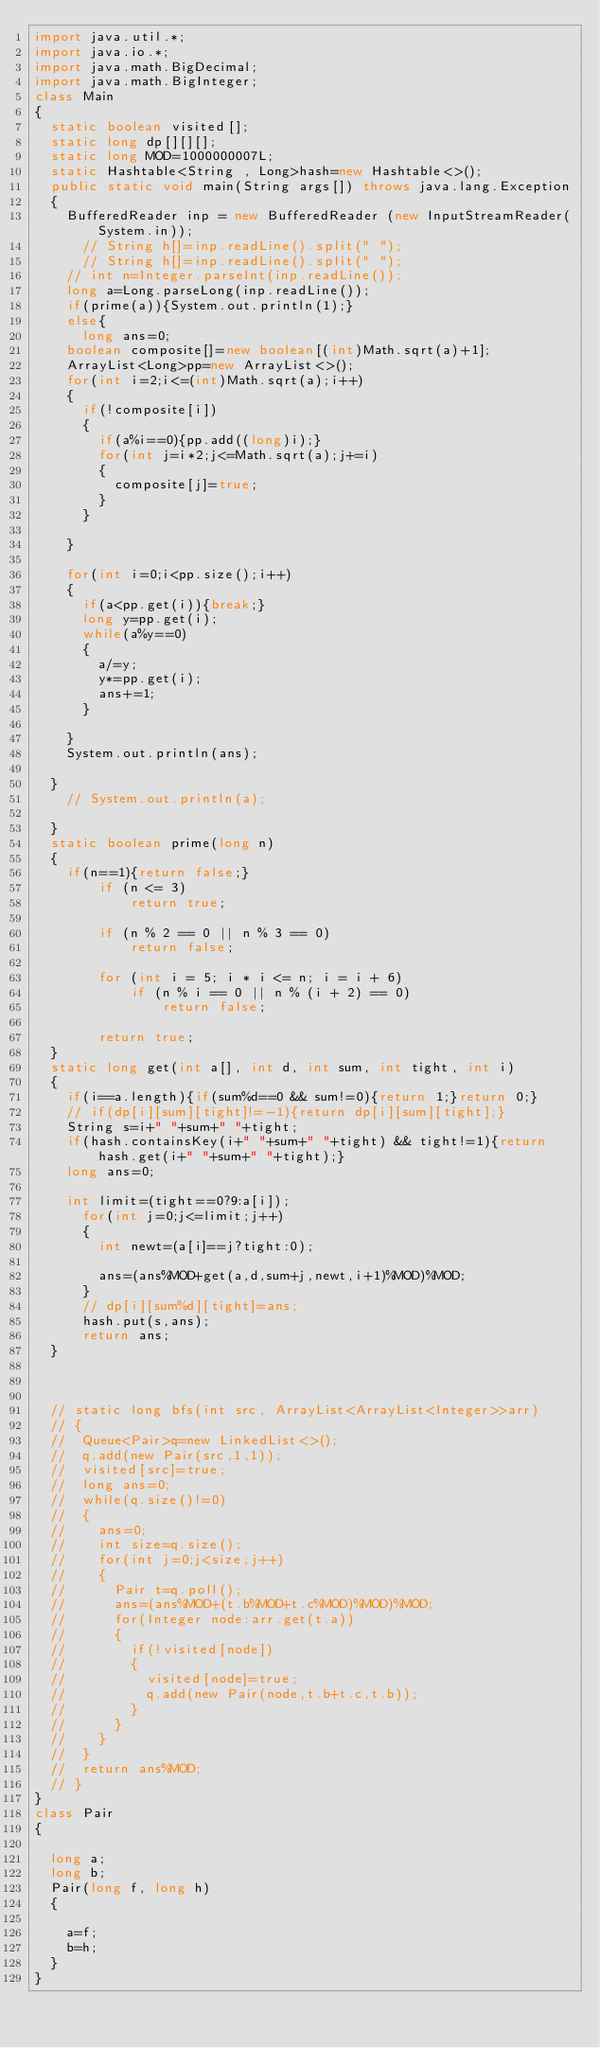<code> <loc_0><loc_0><loc_500><loc_500><_Java_>import java.util.*;
import java.io.*;
import java.math.BigDecimal; 
import java.math.BigInteger; 
class Main
{
	static boolean visited[];
	static long dp[][][];
	static long MOD=1000000007L;
	static Hashtable<String , Long>hash=new Hashtable<>();
	public static void main(String args[]) throws java.lang.Exception
	{
		BufferedReader inp = new BufferedReader (new InputStreamReader(System.in));
			// String h[]=inp.readLine().split(" ");
			// String h[]=inp.readLine().split(" ");
		// int n=Integer.parseInt(inp.readLine());
		long a=Long.parseLong(inp.readLine());
		if(prime(a)){System.out.println(1);}
		else{
			long ans=0;
		boolean composite[]=new boolean[(int)Math.sqrt(a)+1];
		ArrayList<Long>pp=new ArrayList<>();
		for(int i=2;i<=(int)Math.sqrt(a);i++)
		{
			if(!composite[i])
			{
				if(a%i==0){pp.add((long)i);}
				for(int j=i*2;j<=Math.sqrt(a);j+=i)
				{
					composite[j]=true;
				}
			}

		}

		for(int i=0;i<pp.size();i++)
		{
			if(a<pp.get(i)){break;}
			long y=pp.get(i);
			while(a%y==0)
			{
				a/=y;
				y*=pp.get(i);
				ans+=1;
			}

		}
		System.out.println(ans);

	}
		// System.out.println(a);
		
	}
	static boolean prime(long n)
	{
		if(n==1){return false;}
        if (n <= 3) 
            return true; 
  
        if (n % 2 == 0 || n % 3 == 0) 
            return false; 
  
        for (int i = 5; i * i <= n; i = i + 6) 
            if (n % i == 0 || n % (i + 2) == 0) 
                return false; 
  
        return true; 
	}
	static long get(int a[], int d, int sum, int tight, int i)
	{
		if(i==a.length){if(sum%d==0 && sum!=0){return 1;}return 0;}
		// if(dp[i][sum][tight]!=-1){return dp[i][sum][tight];}
		String s=i+" "+sum+" "+tight;
		if(hash.containsKey(i+" "+sum+" "+tight) && tight!=1){return hash.get(i+" "+sum+" "+tight);}
		long ans=0;
		
		int limit=(tight==0?9:a[i]);
			for(int j=0;j<=limit;j++)
			{
				int newt=(a[i]==j?tight:0);

				ans=(ans%MOD+get(a,d,sum+j,newt,i+1)%MOD)%MOD;
			}
			// dp[i][sum%d][tight]=ans;
			hash.put(s,ans);
			return ans;	
	}


	
	// static long bfs(int src, ArrayList<ArrayList<Integer>>arr)
	// {
	// 	Queue<Pair>q=new LinkedList<>();
	// 	q.add(new Pair(src,1,1));
	// 	visited[src]=true;
	// 	long ans=0;
	// 	while(q.size()!=0)
	// 	{
	// 		ans=0;
	// 		int size=q.size();
	// 		for(int j=0;j<size;j++)
	// 		{
	// 			Pair t=q.poll();
	// 			ans=(ans%MOD+(t.b%MOD+t.c%MOD)%MOD)%MOD;
	// 			for(Integer node:arr.get(t.a))
	// 			{
	// 				if(!visited[node])
	// 				{
	// 					visited[node]=true;
	// 					q.add(new Pair(node,t.b+t.c,t.b));
	// 				}
	// 			}
	// 		}
	// 	}
	// 	return ans%MOD;
	// }
}
class Pair
{
	
	long a;
	long b;
	Pair(long f, long h)
	{
		
		a=f;
		b=h;
	}
}</code> 